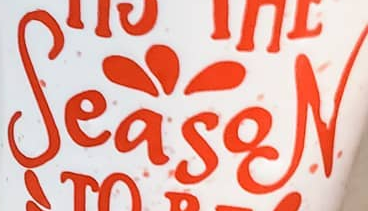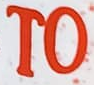Read the text from these images in sequence, separated by a semicolon. SeasoN; TO 